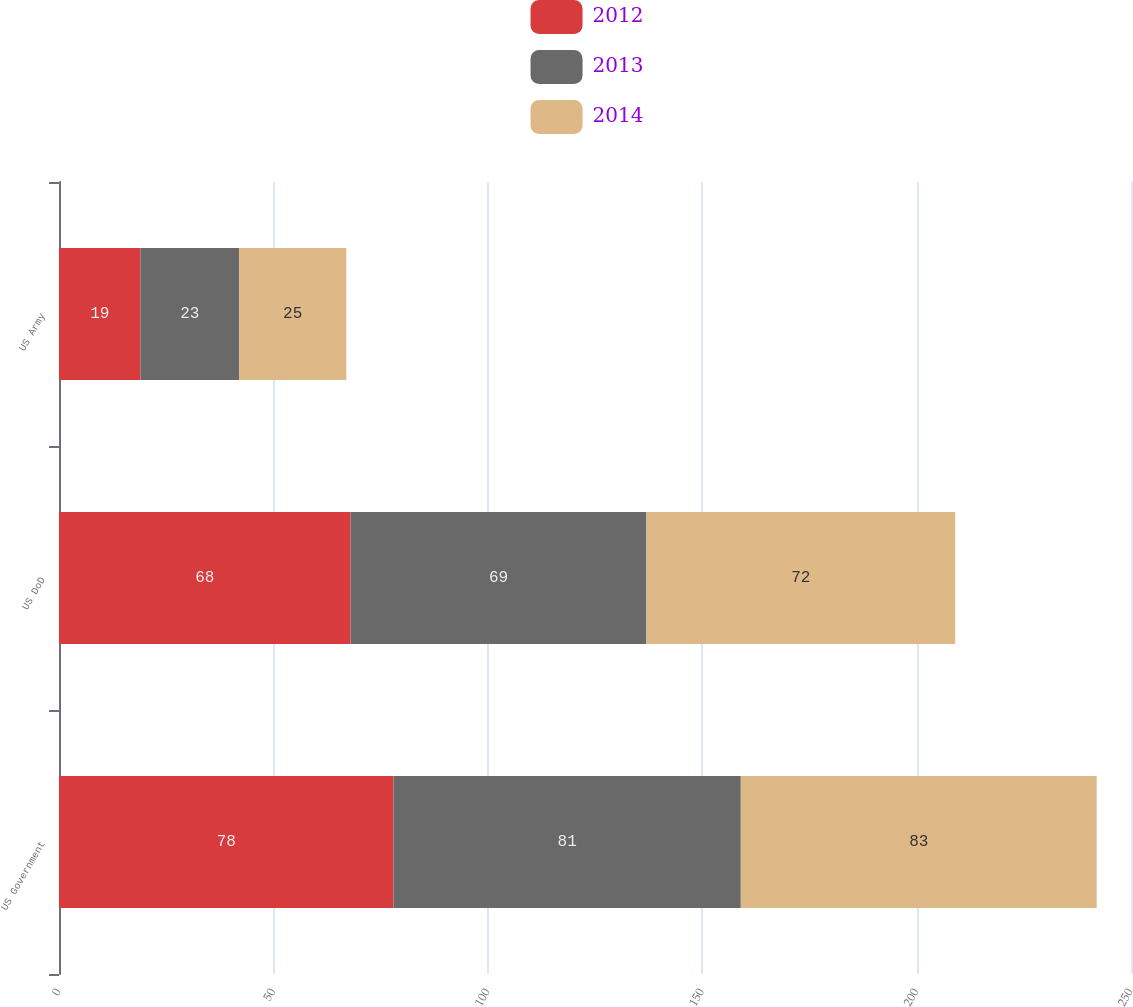Convert chart. <chart><loc_0><loc_0><loc_500><loc_500><stacked_bar_chart><ecel><fcel>US Government<fcel>US DoD<fcel>US Army<nl><fcel>2012<fcel>78<fcel>68<fcel>19<nl><fcel>2013<fcel>81<fcel>69<fcel>23<nl><fcel>2014<fcel>83<fcel>72<fcel>25<nl></chart> 